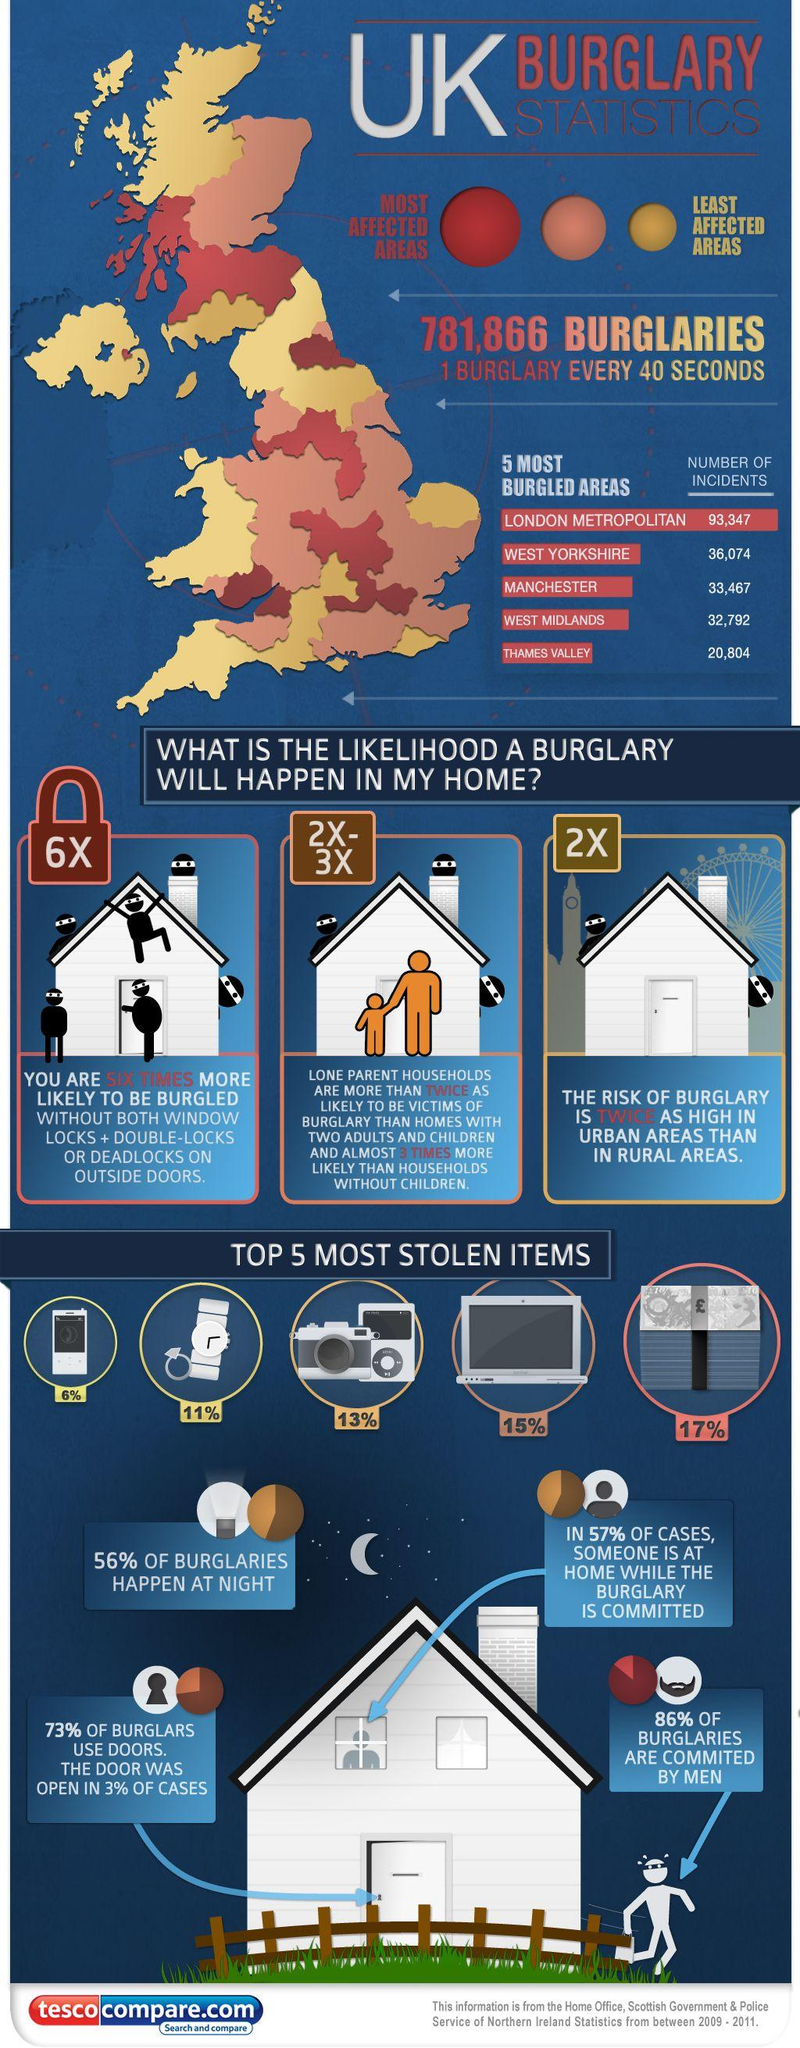Mention a couple of crucial points in this snapshot. The color yellow is used to represent the least affected areas of burglary. According to recent statistics, only 14% of burglaries are not committed by men. According to statistics, only 44% of burglaries do not occur at night. According to a study, a significant percentage of burglars did not use doors during their crimes, with 27% falling into this category. Burglary is a serious crime that affects many communities. The color red is often used to represent the areas that are most affected by burglary. However, there is no definitive answer as to which color, -orange, red, or yellow, is used to represent these areas. It is important to note that the color used to represent the most affected areas of burglary can vary and may not be consistent across different sources. Therefore, it is essential to consult with reliable sources when seeking information about the use of colors to represent burglary-affected areas. 